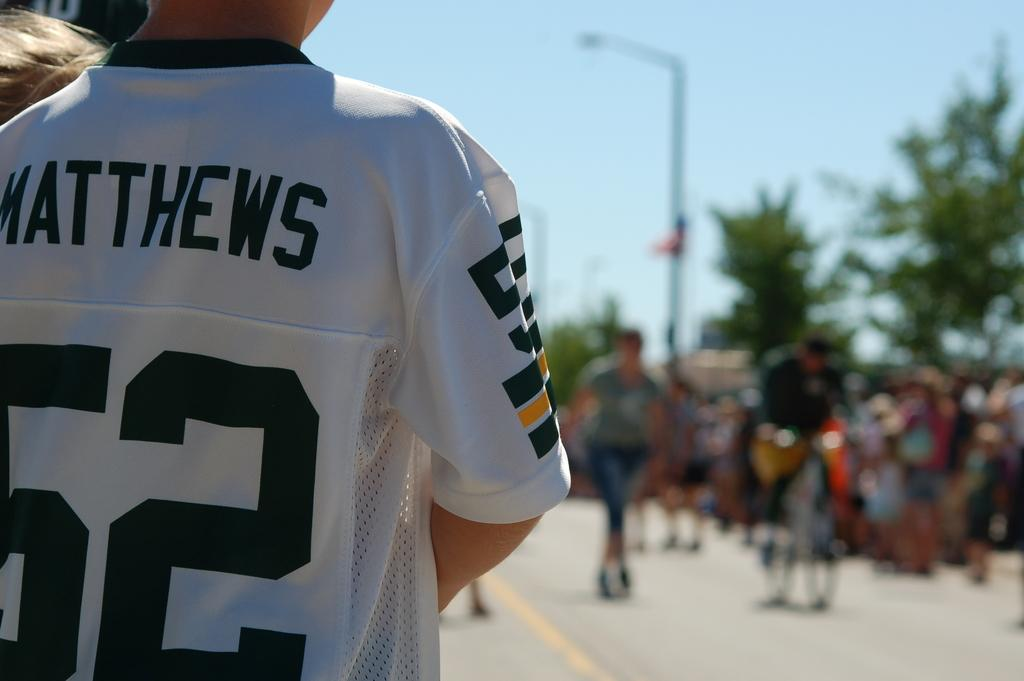<image>
Provide a brief description of the given image. A young person has a Matthews number 52 jersey on. 